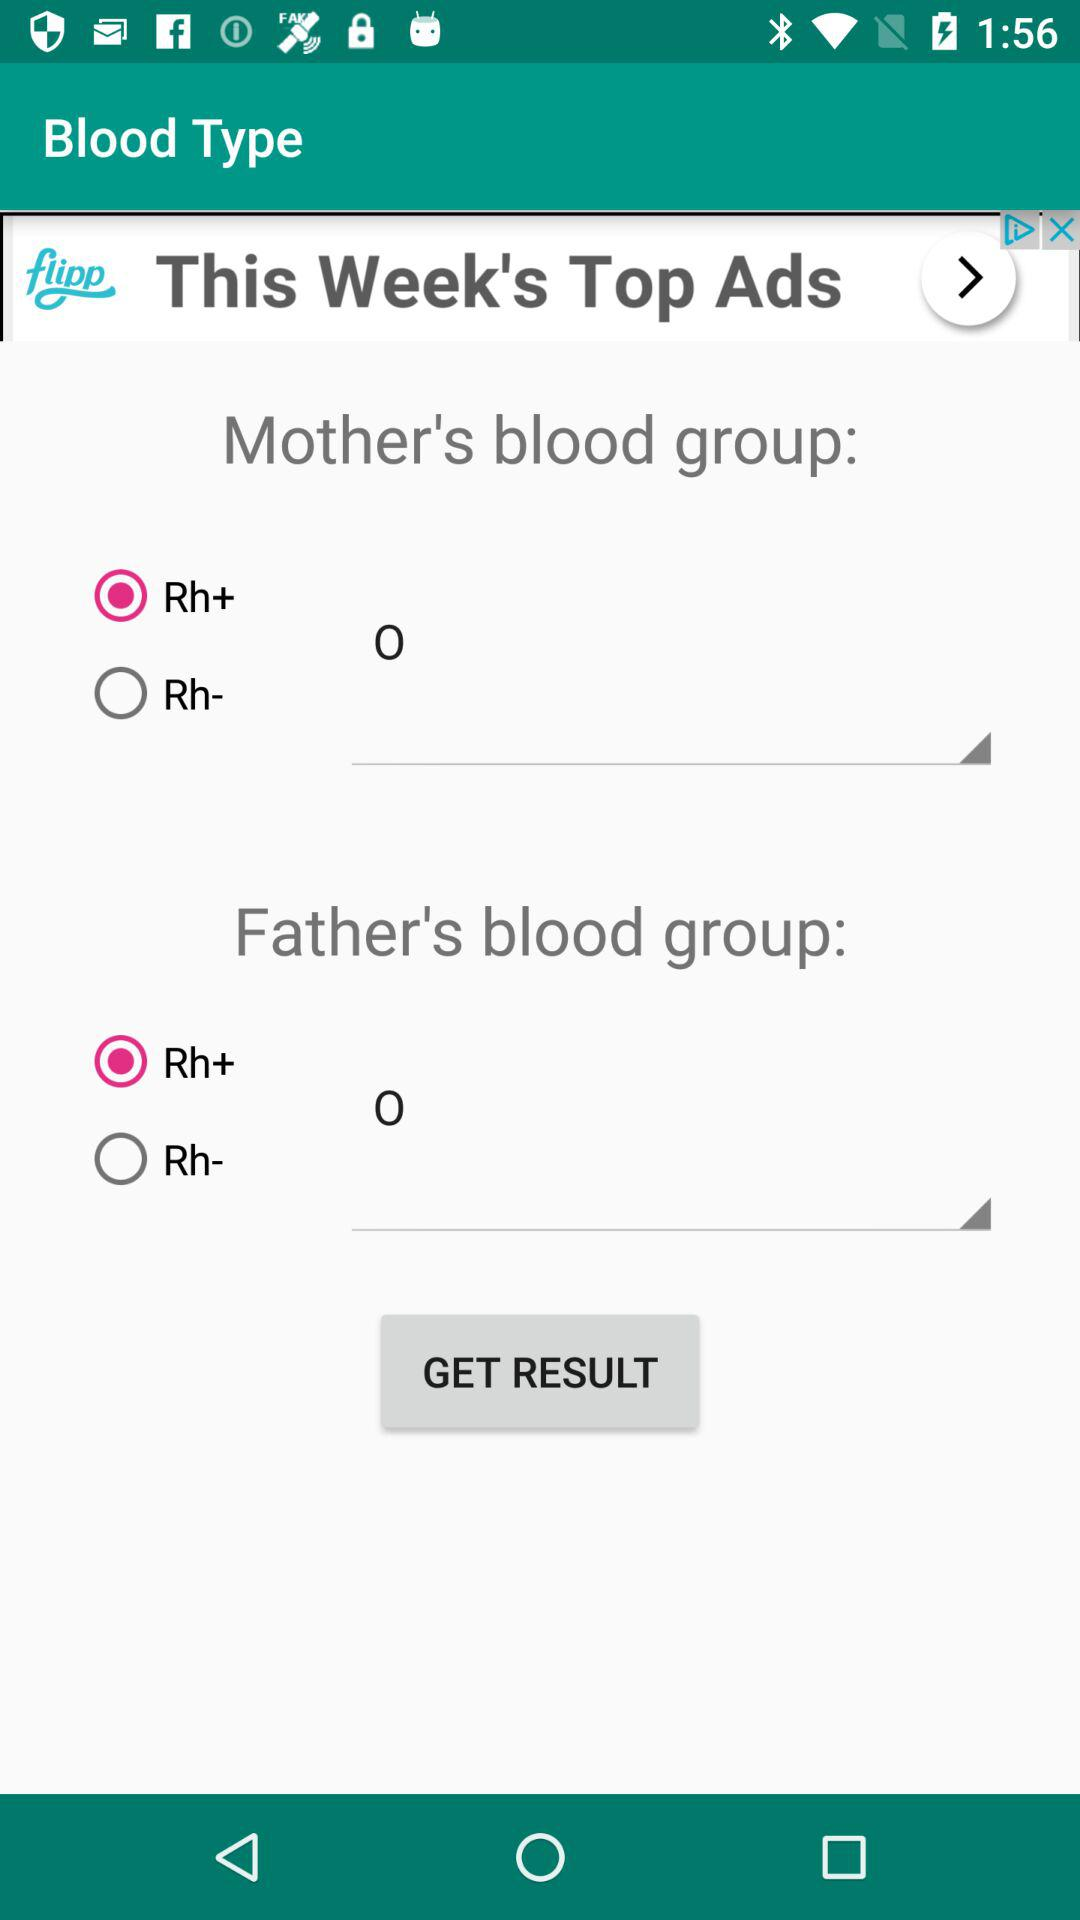What is the selected mother's blood group? The selected mother's blood group is Rh+. 